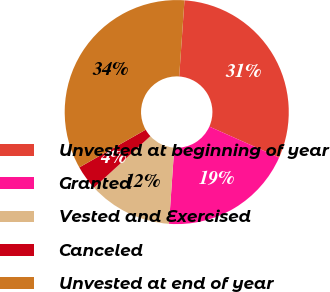Convert chart to OTSL. <chart><loc_0><loc_0><loc_500><loc_500><pie_chart><fcel>Unvested at beginning of year<fcel>Granted<fcel>Vested and Exercised<fcel>Canceled<fcel>Unvested at end of year<nl><fcel>30.56%<fcel>19.44%<fcel>12.12%<fcel>3.56%<fcel>34.32%<nl></chart> 